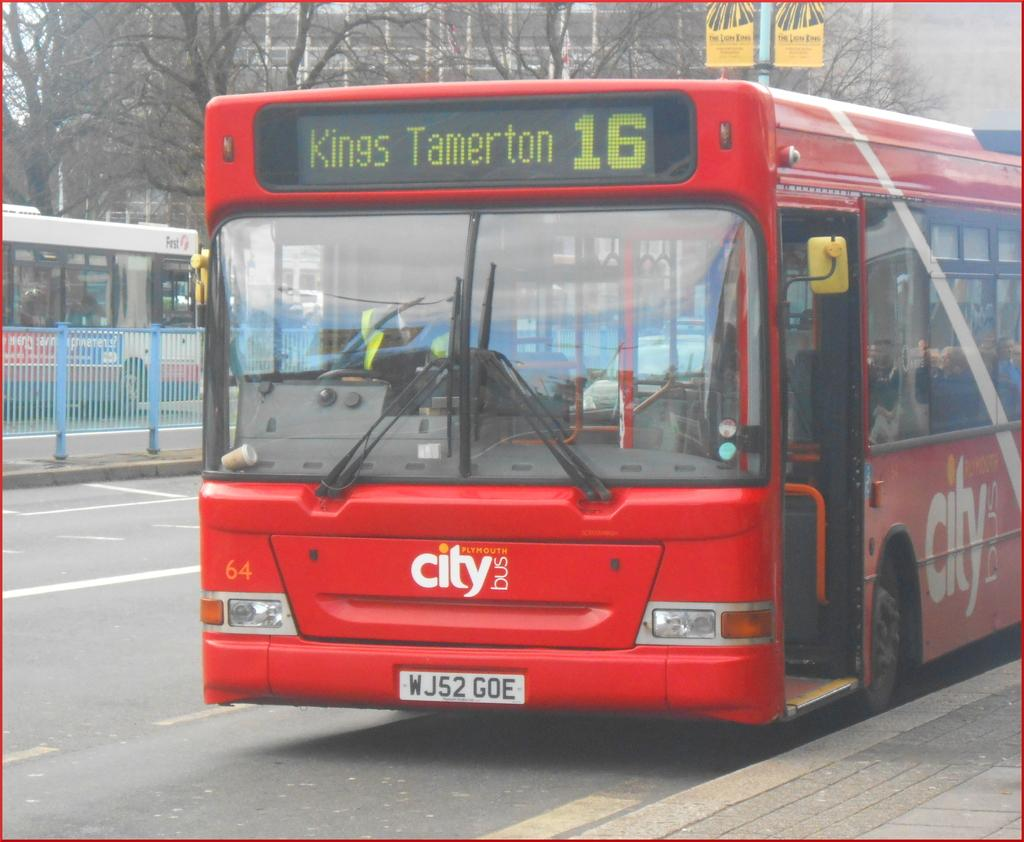Provide a one-sentence caption for the provided image. A red city bus bound for Kings Tamerton 16. 